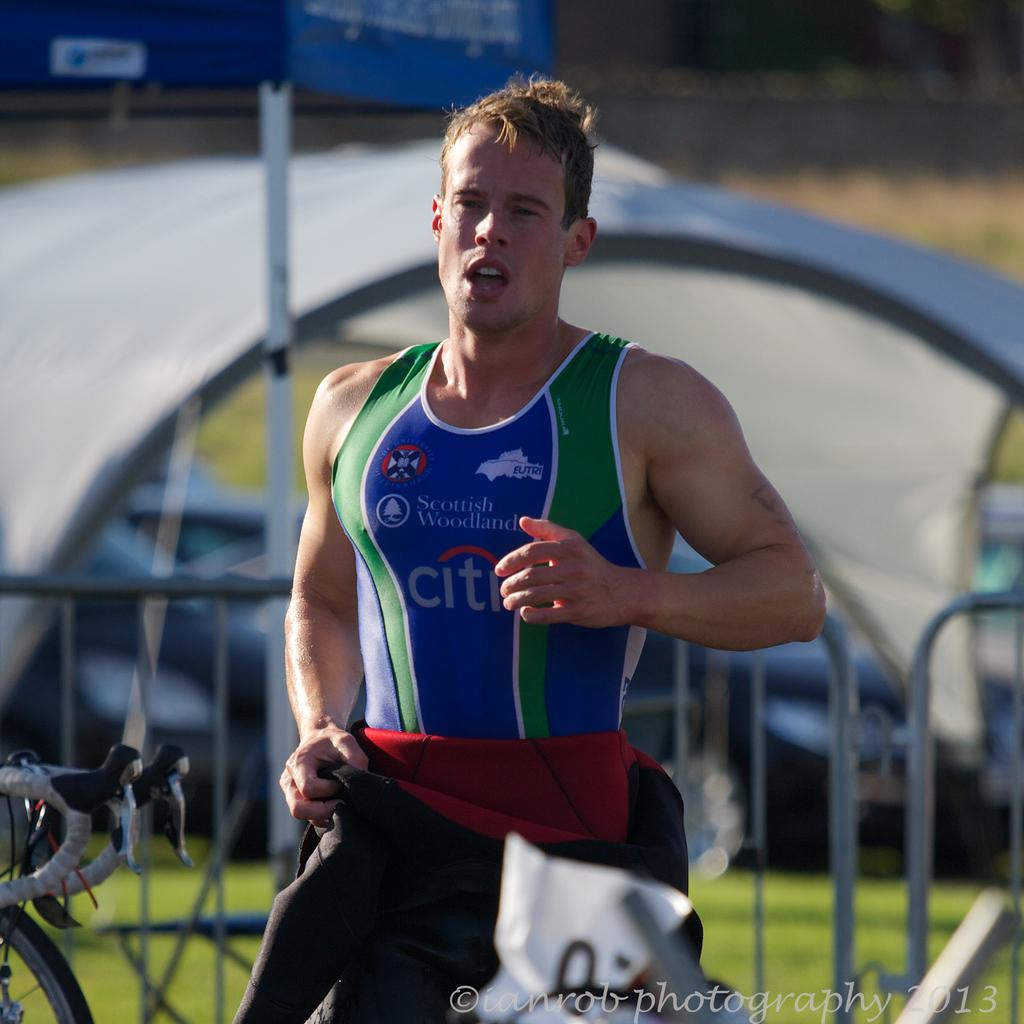<image>
Offer a succinct explanation of the picture presented. A runner sponsored by Scottish Woodland is seen close up. 